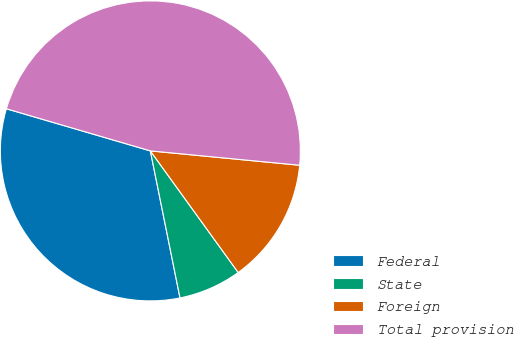<chart> <loc_0><loc_0><loc_500><loc_500><pie_chart><fcel>Federal<fcel>State<fcel>Foreign<fcel>Total provision<nl><fcel>32.7%<fcel>6.79%<fcel>13.52%<fcel>47.0%<nl></chart> 